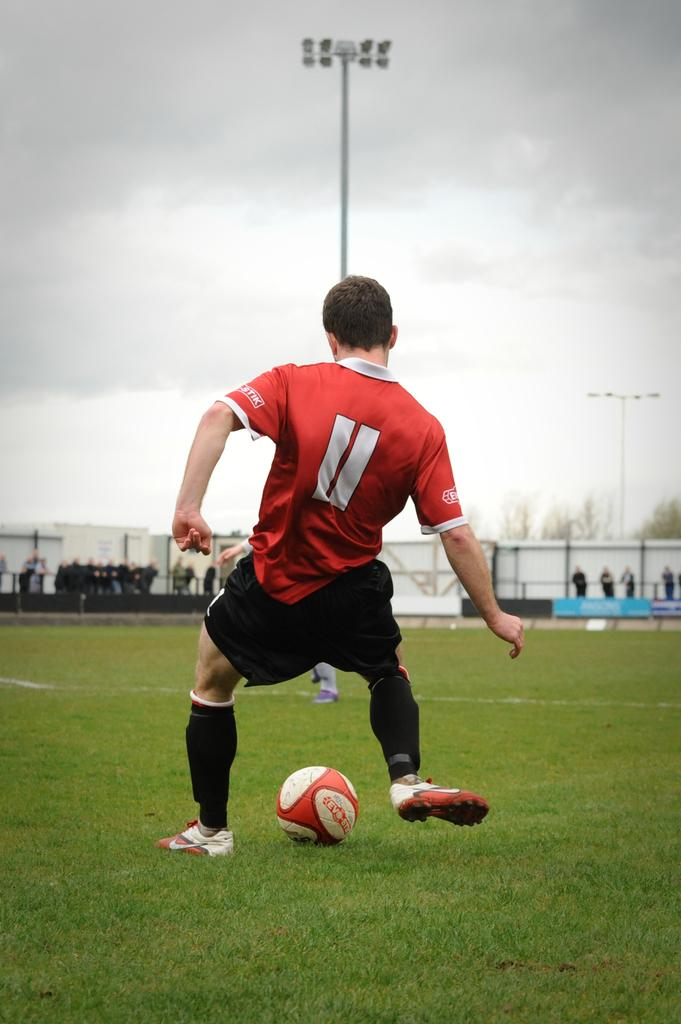<image>
Present a compact description of the photo's key features. Number 11 in red is getting ready to kick the soccer ball. 